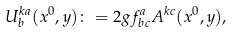<formula> <loc_0><loc_0><loc_500><loc_500>U ^ { k a } _ { b } ( x ^ { 0 } , { y } ) \colon = 2 g f ^ { a } _ { b c } A ^ { k c } ( x ^ { 0 } , { y } ) ,</formula> 